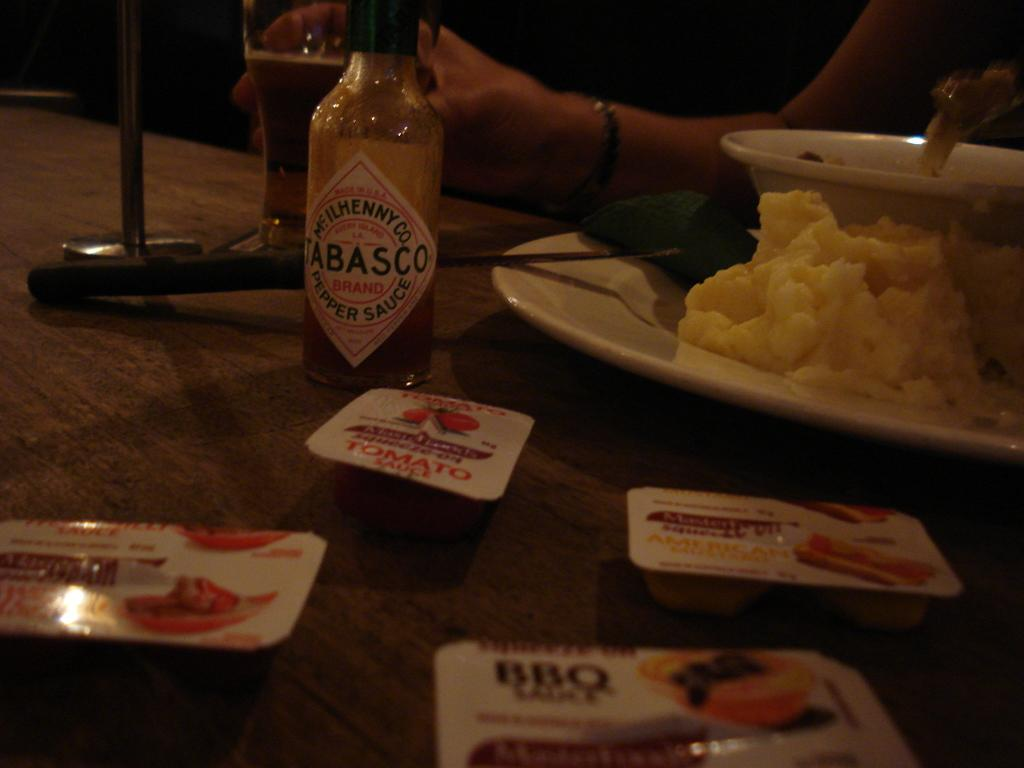<image>
Create a compact narrative representing the image presented. Several condiments including Tabasco sauce and BBQ sauce sit on a table. 